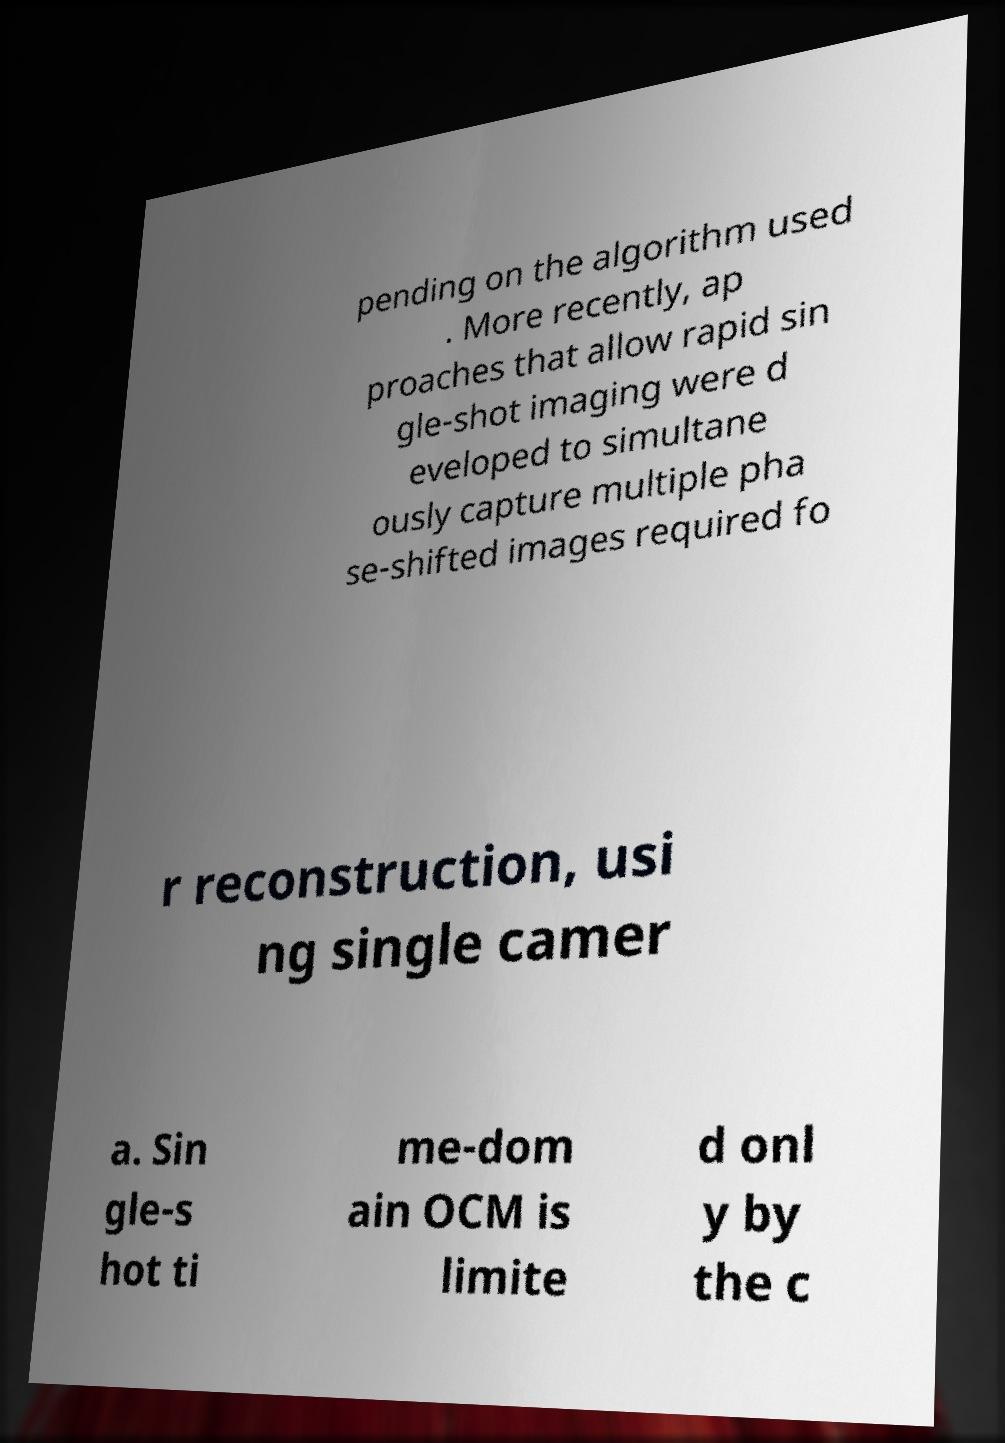Could you assist in decoding the text presented in this image and type it out clearly? pending on the algorithm used . More recently, ap proaches that allow rapid sin gle-shot imaging were d eveloped to simultane ously capture multiple pha se-shifted images required fo r reconstruction, usi ng single camer a. Sin gle-s hot ti me-dom ain OCM is limite d onl y by the c 